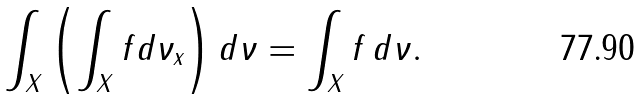<formula> <loc_0><loc_0><loc_500><loc_500>\int _ { X } \left ( \int _ { X } f d \nu _ { x } \right ) d \nu = \int _ { X } f \, d \nu .</formula> 